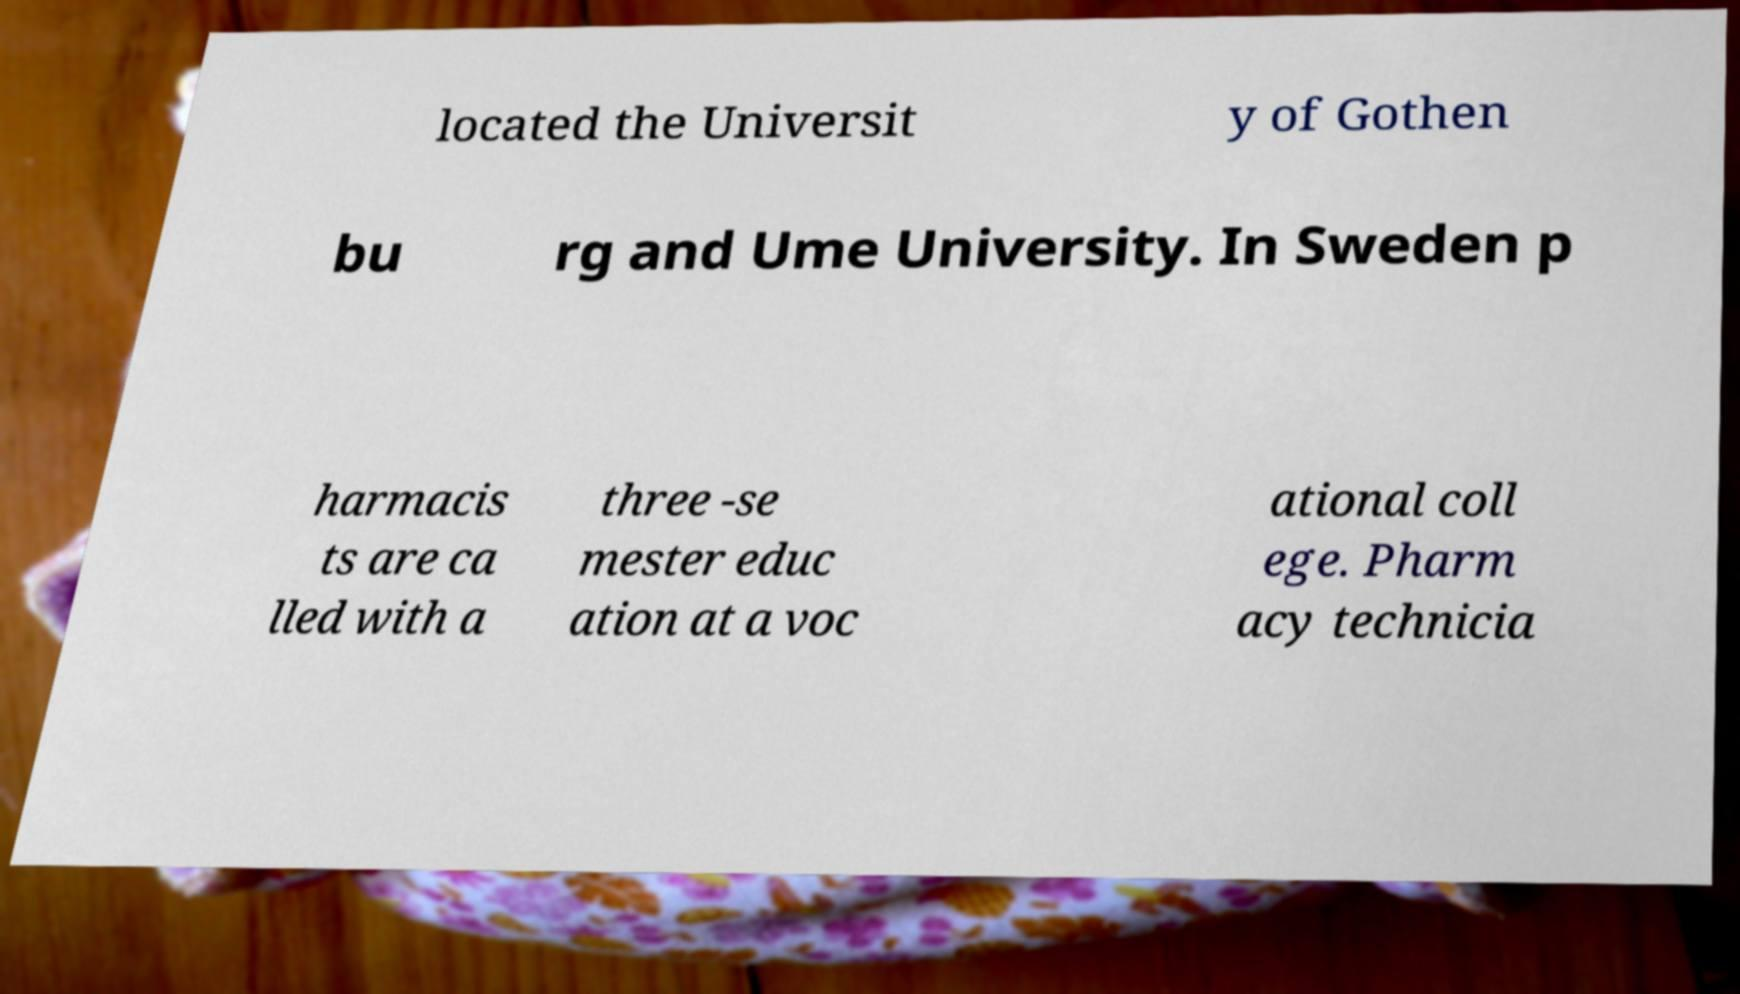I need the written content from this picture converted into text. Can you do that? located the Universit y of Gothen bu rg and Ume University. In Sweden p harmacis ts are ca lled with a three -se mester educ ation at a voc ational coll ege. Pharm acy technicia 